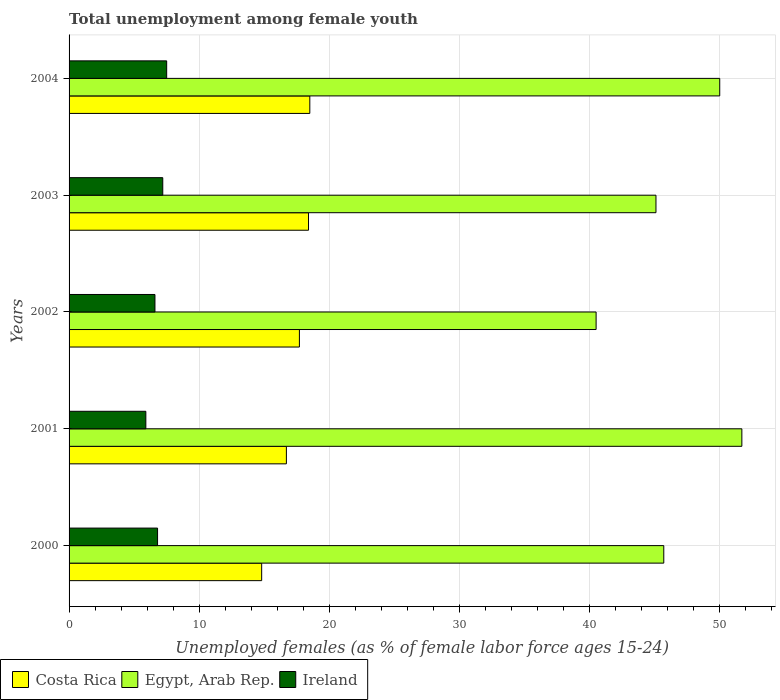Are the number of bars on each tick of the Y-axis equal?
Ensure brevity in your answer.  Yes. How many bars are there on the 3rd tick from the top?
Offer a terse response. 3. How many bars are there on the 2nd tick from the bottom?
Make the answer very short. 3. What is the label of the 4th group of bars from the top?
Your answer should be very brief. 2001. What is the percentage of unemployed females in in Ireland in 2001?
Offer a very short reply. 5.9. Across all years, what is the maximum percentage of unemployed females in in Egypt, Arab Rep.?
Make the answer very short. 51.7. Across all years, what is the minimum percentage of unemployed females in in Ireland?
Provide a short and direct response. 5.9. In which year was the percentage of unemployed females in in Egypt, Arab Rep. maximum?
Ensure brevity in your answer.  2001. In which year was the percentage of unemployed females in in Ireland minimum?
Provide a succinct answer. 2001. What is the difference between the percentage of unemployed females in in Costa Rica in 2000 and that in 2004?
Keep it short and to the point. -3.7. What is the difference between the percentage of unemployed females in in Costa Rica in 2004 and the percentage of unemployed females in in Ireland in 2001?
Make the answer very short. 12.6. What is the average percentage of unemployed females in in Egypt, Arab Rep. per year?
Your answer should be very brief. 46.6. In the year 2003, what is the difference between the percentage of unemployed females in in Costa Rica and percentage of unemployed females in in Egypt, Arab Rep.?
Provide a short and direct response. -26.7. What is the ratio of the percentage of unemployed females in in Costa Rica in 2003 to that in 2004?
Keep it short and to the point. 0.99. Is the percentage of unemployed females in in Costa Rica in 2001 less than that in 2003?
Make the answer very short. Yes. What is the difference between the highest and the second highest percentage of unemployed females in in Costa Rica?
Your answer should be compact. 0.1. What is the difference between the highest and the lowest percentage of unemployed females in in Egypt, Arab Rep.?
Ensure brevity in your answer.  11.2. In how many years, is the percentage of unemployed females in in Egypt, Arab Rep. greater than the average percentage of unemployed females in in Egypt, Arab Rep. taken over all years?
Your response must be concise. 2. Is the sum of the percentage of unemployed females in in Costa Rica in 2000 and 2001 greater than the maximum percentage of unemployed females in in Egypt, Arab Rep. across all years?
Your answer should be very brief. No. What does the 2nd bar from the top in 2004 represents?
Your response must be concise. Egypt, Arab Rep. What does the 3rd bar from the bottom in 2003 represents?
Make the answer very short. Ireland. How many bars are there?
Offer a very short reply. 15. Are all the bars in the graph horizontal?
Your answer should be very brief. Yes. What is the difference between two consecutive major ticks on the X-axis?
Offer a terse response. 10. Where does the legend appear in the graph?
Your answer should be very brief. Bottom left. How are the legend labels stacked?
Your answer should be compact. Horizontal. What is the title of the graph?
Offer a terse response. Total unemployment among female youth. What is the label or title of the X-axis?
Make the answer very short. Unemployed females (as % of female labor force ages 15-24). What is the label or title of the Y-axis?
Make the answer very short. Years. What is the Unemployed females (as % of female labor force ages 15-24) in Costa Rica in 2000?
Provide a short and direct response. 14.8. What is the Unemployed females (as % of female labor force ages 15-24) of Egypt, Arab Rep. in 2000?
Ensure brevity in your answer.  45.7. What is the Unemployed females (as % of female labor force ages 15-24) of Ireland in 2000?
Provide a short and direct response. 6.8. What is the Unemployed females (as % of female labor force ages 15-24) of Costa Rica in 2001?
Provide a short and direct response. 16.7. What is the Unemployed females (as % of female labor force ages 15-24) in Egypt, Arab Rep. in 2001?
Your response must be concise. 51.7. What is the Unemployed females (as % of female labor force ages 15-24) of Ireland in 2001?
Offer a terse response. 5.9. What is the Unemployed females (as % of female labor force ages 15-24) in Costa Rica in 2002?
Offer a terse response. 17.7. What is the Unemployed females (as % of female labor force ages 15-24) in Egypt, Arab Rep. in 2002?
Offer a very short reply. 40.5. What is the Unemployed females (as % of female labor force ages 15-24) in Ireland in 2002?
Make the answer very short. 6.6. What is the Unemployed females (as % of female labor force ages 15-24) in Costa Rica in 2003?
Make the answer very short. 18.4. What is the Unemployed females (as % of female labor force ages 15-24) of Egypt, Arab Rep. in 2003?
Offer a terse response. 45.1. What is the Unemployed females (as % of female labor force ages 15-24) of Ireland in 2003?
Keep it short and to the point. 7.2. What is the Unemployed females (as % of female labor force ages 15-24) in Ireland in 2004?
Offer a terse response. 7.5. Across all years, what is the maximum Unemployed females (as % of female labor force ages 15-24) in Costa Rica?
Keep it short and to the point. 18.5. Across all years, what is the maximum Unemployed females (as % of female labor force ages 15-24) of Egypt, Arab Rep.?
Offer a very short reply. 51.7. Across all years, what is the maximum Unemployed females (as % of female labor force ages 15-24) of Ireland?
Provide a succinct answer. 7.5. Across all years, what is the minimum Unemployed females (as % of female labor force ages 15-24) of Costa Rica?
Ensure brevity in your answer.  14.8. Across all years, what is the minimum Unemployed females (as % of female labor force ages 15-24) in Egypt, Arab Rep.?
Your answer should be very brief. 40.5. Across all years, what is the minimum Unemployed females (as % of female labor force ages 15-24) in Ireland?
Your answer should be compact. 5.9. What is the total Unemployed females (as % of female labor force ages 15-24) in Costa Rica in the graph?
Provide a succinct answer. 86.1. What is the total Unemployed females (as % of female labor force ages 15-24) in Egypt, Arab Rep. in the graph?
Provide a succinct answer. 233. What is the total Unemployed females (as % of female labor force ages 15-24) of Ireland in the graph?
Make the answer very short. 34. What is the difference between the Unemployed females (as % of female labor force ages 15-24) of Costa Rica in 2000 and that in 2001?
Provide a succinct answer. -1.9. What is the difference between the Unemployed females (as % of female labor force ages 15-24) in Egypt, Arab Rep. in 2000 and that in 2001?
Offer a terse response. -6. What is the difference between the Unemployed females (as % of female labor force ages 15-24) in Ireland in 2000 and that in 2001?
Your answer should be very brief. 0.9. What is the difference between the Unemployed females (as % of female labor force ages 15-24) of Egypt, Arab Rep. in 2000 and that in 2002?
Keep it short and to the point. 5.2. What is the difference between the Unemployed females (as % of female labor force ages 15-24) of Costa Rica in 2000 and that in 2003?
Make the answer very short. -3.6. What is the difference between the Unemployed females (as % of female labor force ages 15-24) of Ireland in 2000 and that in 2003?
Offer a very short reply. -0.4. What is the difference between the Unemployed females (as % of female labor force ages 15-24) in Costa Rica in 2000 and that in 2004?
Make the answer very short. -3.7. What is the difference between the Unemployed females (as % of female labor force ages 15-24) in Ireland in 2000 and that in 2004?
Keep it short and to the point. -0.7. What is the difference between the Unemployed females (as % of female labor force ages 15-24) of Costa Rica in 2001 and that in 2003?
Your response must be concise. -1.7. What is the difference between the Unemployed females (as % of female labor force ages 15-24) in Costa Rica in 2001 and that in 2004?
Provide a succinct answer. -1.8. What is the difference between the Unemployed females (as % of female labor force ages 15-24) of Egypt, Arab Rep. in 2001 and that in 2004?
Offer a very short reply. 1.7. What is the difference between the Unemployed females (as % of female labor force ages 15-24) of Ireland in 2001 and that in 2004?
Make the answer very short. -1.6. What is the difference between the Unemployed females (as % of female labor force ages 15-24) of Costa Rica in 2002 and that in 2003?
Make the answer very short. -0.7. What is the difference between the Unemployed females (as % of female labor force ages 15-24) of Ireland in 2002 and that in 2004?
Your answer should be very brief. -0.9. What is the difference between the Unemployed females (as % of female labor force ages 15-24) in Costa Rica in 2003 and that in 2004?
Your response must be concise. -0.1. What is the difference between the Unemployed females (as % of female labor force ages 15-24) of Costa Rica in 2000 and the Unemployed females (as % of female labor force ages 15-24) of Egypt, Arab Rep. in 2001?
Offer a very short reply. -36.9. What is the difference between the Unemployed females (as % of female labor force ages 15-24) of Egypt, Arab Rep. in 2000 and the Unemployed females (as % of female labor force ages 15-24) of Ireland in 2001?
Keep it short and to the point. 39.8. What is the difference between the Unemployed females (as % of female labor force ages 15-24) in Costa Rica in 2000 and the Unemployed females (as % of female labor force ages 15-24) in Egypt, Arab Rep. in 2002?
Ensure brevity in your answer.  -25.7. What is the difference between the Unemployed females (as % of female labor force ages 15-24) of Egypt, Arab Rep. in 2000 and the Unemployed females (as % of female labor force ages 15-24) of Ireland in 2002?
Ensure brevity in your answer.  39.1. What is the difference between the Unemployed females (as % of female labor force ages 15-24) in Costa Rica in 2000 and the Unemployed females (as % of female labor force ages 15-24) in Egypt, Arab Rep. in 2003?
Ensure brevity in your answer.  -30.3. What is the difference between the Unemployed females (as % of female labor force ages 15-24) in Egypt, Arab Rep. in 2000 and the Unemployed females (as % of female labor force ages 15-24) in Ireland in 2003?
Keep it short and to the point. 38.5. What is the difference between the Unemployed females (as % of female labor force ages 15-24) in Costa Rica in 2000 and the Unemployed females (as % of female labor force ages 15-24) in Egypt, Arab Rep. in 2004?
Give a very brief answer. -35.2. What is the difference between the Unemployed females (as % of female labor force ages 15-24) of Costa Rica in 2000 and the Unemployed females (as % of female labor force ages 15-24) of Ireland in 2004?
Give a very brief answer. 7.3. What is the difference between the Unemployed females (as % of female labor force ages 15-24) of Egypt, Arab Rep. in 2000 and the Unemployed females (as % of female labor force ages 15-24) of Ireland in 2004?
Offer a very short reply. 38.2. What is the difference between the Unemployed females (as % of female labor force ages 15-24) of Costa Rica in 2001 and the Unemployed females (as % of female labor force ages 15-24) of Egypt, Arab Rep. in 2002?
Offer a very short reply. -23.8. What is the difference between the Unemployed females (as % of female labor force ages 15-24) of Costa Rica in 2001 and the Unemployed females (as % of female labor force ages 15-24) of Ireland in 2002?
Offer a very short reply. 10.1. What is the difference between the Unemployed females (as % of female labor force ages 15-24) of Egypt, Arab Rep. in 2001 and the Unemployed females (as % of female labor force ages 15-24) of Ireland in 2002?
Ensure brevity in your answer.  45.1. What is the difference between the Unemployed females (as % of female labor force ages 15-24) of Costa Rica in 2001 and the Unemployed females (as % of female labor force ages 15-24) of Egypt, Arab Rep. in 2003?
Offer a very short reply. -28.4. What is the difference between the Unemployed females (as % of female labor force ages 15-24) of Egypt, Arab Rep. in 2001 and the Unemployed females (as % of female labor force ages 15-24) of Ireland in 2003?
Ensure brevity in your answer.  44.5. What is the difference between the Unemployed females (as % of female labor force ages 15-24) of Costa Rica in 2001 and the Unemployed females (as % of female labor force ages 15-24) of Egypt, Arab Rep. in 2004?
Keep it short and to the point. -33.3. What is the difference between the Unemployed females (as % of female labor force ages 15-24) of Costa Rica in 2001 and the Unemployed females (as % of female labor force ages 15-24) of Ireland in 2004?
Keep it short and to the point. 9.2. What is the difference between the Unemployed females (as % of female labor force ages 15-24) in Egypt, Arab Rep. in 2001 and the Unemployed females (as % of female labor force ages 15-24) in Ireland in 2004?
Provide a short and direct response. 44.2. What is the difference between the Unemployed females (as % of female labor force ages 15-24) in Costa Rica in 2002 and the Unemployed females (as % of female labor force ages 15-24) in Egypt, Arab Rep. in 2003?
Make the answer very short. -27.4. What is the difference between the Unemployed females (as % of female labor force ages 15-24) in Egypt, Arab Rep. in 2002 and the Unemployed females (as % of female labor force ages 15-24) in Ireland in 2003?
Offer a very short reply. 33.3. What is the difference between the Unemployed females (as % of female labor force ages 15-24) in Costa Rica in 2002 and the Unemployed females (as % of female labor force ages 15-24) in Egypt, Arab Rep. in 2004?
Provide a short and direct response. -32.3. What is the difference between the Unemployed females (as % of female labor force ages 15-24) in Costa Rica in 2002 and the Unemployed females (as % of female labor force ages 15-24) in Ireland in 2004?
Give a very brief answer. 10.2. What is the difference between the Unemployed females (as % of female labor force ages 15-24) in Egypt, Arab Rep. in 2002 and the Unemployed females (as % of female labor force ages 15-24) in Ireland in 2004?
Give a very brief answer. 33. What is the difference between the Unemployed females (as % of female labor force ages 15-24) in Costa Rica in 2003 and the Unemployed females (as % of female labor force ages 15-24) in Egypt, Arab Rep. in 2004?
Ensure brevity in your answer.  -31.6. What is the difference between the Unemployed females (as % of female labor force ages 15-24) of Egypt, Arab Rep. in 2003 and the Unemployed females (as % of female labor force ages 15-24) of Ireland in 2004?
Give a very brief answer. 37.6. What is the average Unemployed females (as % of female labor force ages 15-24) in Costa Rica per year?
Provide a succinct answer. 17.22. What is the average Unemployed females (as % of female labor force ages 15-24) of Egypt, Arab Rep. per year?
Your response must be concise. 46.6. What is the average Unemployed females (as % of female labor force ages 15-24) in Ireland per year?
Provide a short and direct response. 6.8. In the year 2000, what is the difference between the Unemployed females (as % of female labor force ages 15-24) in Costa Rica and Unemployed females (as % of female labor force ages 15-24) in Egypt, Arab Rep.?
Offer a very short reply. -30.9. In the year 2000, what is the difference between the Unemployed females (as % of female labor force ages 15-24) in Costa Rica and Unemployed females (as % of female labor force ages 15-24) in Ireland?
Keep it short and to the point. 8. In the year 2000, what is the difference between the Unemployed females (as % of female labor force ages 15-24) in Egypt, Arab Rep. and Unemployed females (as % of female labor force ages 15-24) in Ireland?
Give a very brief answer. 38.9. In the year 2001, what is the difference between the Unemployed females (as % of female labor force ages 15-24) of Costa Rica and Unemployed females (as % of female labor force ages 15-24) of Egypt, Arab Rep.?
Make the answer very short. -35. In the year 2001, what is the difference between the Unemployed females (as % of female labor force ages 15-24) in Egypt, Arab Rep. and Unemployed females (as % of female labor force ages 15-24) in Ireland?
Your answer should be very brief. 45.8. In the year 2002, what is the difference between the Unemployed females (as % of female labor force ages 15-24) of Costa Rica and Unemployed females (as % of female labor force ages 15-24) of Egypt, Arab Rep.?
Provide a short and direct response. -22.8. In the year 2002, what is the difference between the Unemployed females (as % of female labor force ages 15-24) in Egypt, Arab Rep. and Unemployed females (as % of female labor force ages 15-24) in Ireland?
Give a very brief answer. 33.9. In the year 2003, what is the difference between the Unemployed females (as % of female labor force ages 15-24) in Costa Rica and Unemployed females (as % of female labor force ages 15-24) in Egypt, Arab Rep.?
Provide a short and direct response. -26.7. In the year 2003, what is the difference between the Unemployed females (as % of female labor force ages 15-24) of Egypt, Arab Rep. and Unemployed females (as % of female labor force ages 15-24) of Ireland?
Offer a very short reply. 37.9. In the year 2004, what is the difference between the Unemployed females (as % of female labor force ages 15-24) in Costa Rica and Unemployed females (as % of female labor force ages 15-24) in Egypt, Arab Rep.?
Keep it short and to the point. -31.5. In the year 2004, what is the difference between the Unemployed females (as % of female labor force ages 15-24) of Egypt, Arab Rep. and Unemployed females (as % of female labor force ages 15-24) of Ireland?
Your answer should be very brief. 42.5. What is the ratio of the Unemployed females (as % of female labor force ages 15-24) of Costa Rica in 2000 to that in 2001?
Provide a succinct answer. 0.89. What is the ratio of the Unemployed females (as % of female labor force ages 15-24) in Egypt, Arab Rep. in 2000 to that in 2001?
Your response must be concise. 0.88. What is the ratio of the Unemployed females (as % of female labor force ages 15-24) of Ireland in 2000 to that in 2001?
Your answer should be very brief. 1.15. What is the ratio of the Unemployed females (as % of female labor force ages 15-24) in Costa Rica in 2000 to that in 2002?
Give a very brief answer. 0.84. What is the ratio of the Unemployed females (as % of female labor force ages 15-24) of Egypt, Arab Rep. in 2000 to that in 2002?
Keep it short and to the point. 1.13. What is the ratio of the Unemployed females (as % of female labor force ages 15-24) of Ireland in 2000 to that in 2002?
Provide a succinct answer. 1.03. What is the ratio of the Unemployed females (as % of female labor force ages 15-24) in Costa Rica in 2000 to that in 2003?
Keep it short and to the point. 0.8. What is the ratio of the Unemployed females (as % of female labor force ages 15-24) in Egypt, Arab Rep. in 2000 to that in 2003?
Keep it short and to the point. 1.01. What is the ratio of the Unemployed females (as % of female labor force ages 15-24) of Costa Rica in 2000 to that in 2004?
Provide a succinct answer. 0.8. What is the ratio of the Unemployed females (as % of female labor force ages 15-24) in Egypt, Arab Rep. in 2000 to that in 2004?
Offer a terse response. 0.91. What is the ratio of the Unemployed females (as % of female labor force ages 15-24) in Ireland in 2000 to that in 2004?
Provide a succinct answer. 0.91. What is the ratio of the Unemployed females (as % of female labor force ages 15-24) of Costa Rica in 2001 to that in 2002?
Your answer should be very brief. 0.94. What is the ratio of the Unemployed females (as % of female labor force ages 15-24) of Egypt, Arab Rep. in 2001 to that in 2002?
Provide a succinct answer. 1.28. What is the ratio of the Unemployed females (as % of female labor force ages 15-24) in Ireland in 2001 to that in 2002?
Your answer should be compact. 0.89. What is the ratio of the Unemployed females (as % of female labor force ages 15-24) of Costa Rica in 2001 to that in 2003?
Offer a very short reply. 0.91. What is the ratio of the Unemployed females (as % of female labor force ages 15-24) in Egypt, Arab Rep. in 2001 to that in 2003?
Give a very brief answer. 1.15. What is the ratio of the Unemployed females (as % of female labor force ages 15-24) in Ireland in 2001 to that in 2003?
Give a very brief answer. 0.82. What is the ratio of the Unemployed females (as % of female labor force ages 15-24) in Costa Rica in 2001 to that in 2004?
Your answer should be compact. 0.9. What is the ratio of the Unemployed females (as % of female labor force ages 15-24) in Egypt, Arab Rep. in 2001 to that in 2004?
Give a very brief answer. 1.03. What is the ratio of the Unemployed females (as % of female labor force ages 15-24) in Ireland in 2001 to that in 2004?
Provide a short and direct response. 0.79. What is the ratio of the Unemployed females (as % of female labor force ages 15-24) of Egypt, Arab Rep. in 2002 to that in 2003?
Offer a very short reply. 0.9. What is the ratio of the Unemployed females (as % of female labor force ages 15-24) of Costa Rica in 2002 to that in 2004?
Keep it short and to the point. 0.96. What is the ratio of the Unemployed females (as % of female labor force ages 15-24) of Egypt, Arab Rep. in 2002 to that in 2004?
Your answer should be compact. 0.81. What is the ratio of the Unemployed females (as % of female labor force ages 15-24) of Costa Rica in 2003 to that in 2004?
Offer a terse response. 0.99. What is the ratio of the Unemployed females (as % of female labor force ages 15-24) of Egypt, Arab Rep. in 2003 to that in 2004?
Ensure brevity in your answer.  0.9. What is the ratio of the Unemployed females (as % of female labor force ages 15-24) of Ireland in 2003 to that in 2004?
Your answer should be compact. 0.96. What is the difference between the highest and the second highest Unemployed females (as % of female labor force ages 15-24) in Egypt, Arab Rep.?
Keep it short and to the point. 1.7. What is the difference between the highest and the second highest Unemployed females (as % of female labor force ages 15-24) of Ireland?
Give a very brief answer. 0.3. What is the difference between the highest and the lowest Unemployed females (as % of female labor force ages 15-24) in Costa Rica?
Offer a very short reply. 3.7. 